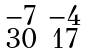Convert formula to latex. <formula><loc_0><loc_0><loc_500><loc_500>\begin{smallmatrix} - 7 & - 4 \\ 3 0 & 1 7 \end{smallmatrix}</formula> 